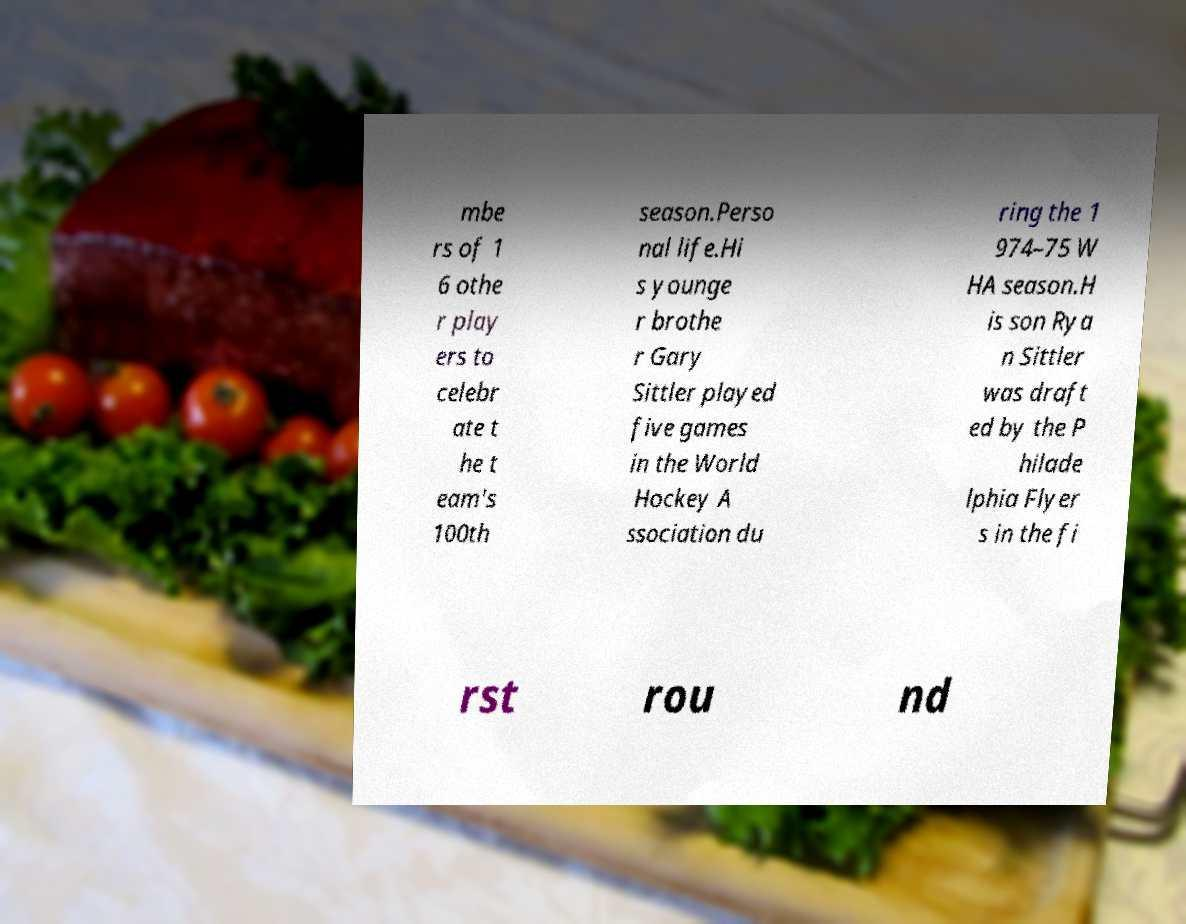Please identify and transcribe the text found in this image. mbe rs of 1 6 othe r play ers to celebr ate t he t eam's 100th season.Perso nal life.Hi s younge r brothe r Gary Sittler played five games in the World Hockey A ssociation du ring the 1 974–75 W HA season.H is son Rya n Sittler was draft ed by the P hilade lphia Flyer s in the fi rst rou nd 